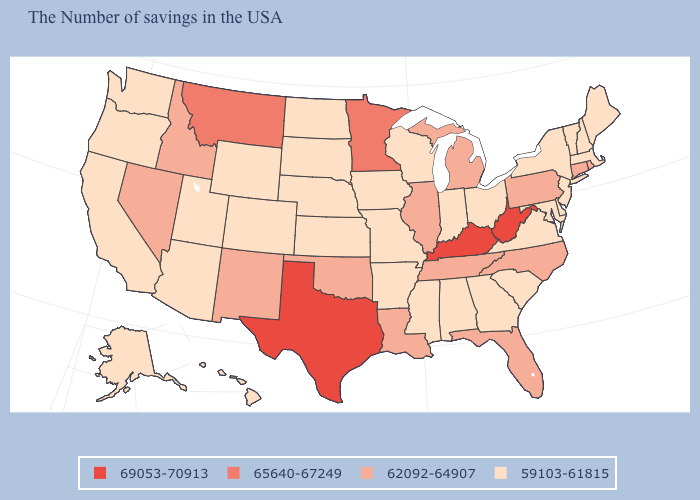What is the lowest value in states that border Tennessee?
Concise answer only. 59103-61815. What is the value of Vermont?
Give a very brief answer. 59103-61815. How many symbols are there in the legend?
Write a very short answer. 4. Name the states that have a value in the range 59103-61815?
Keep it brief. Maine, Massachusetts, New Hampshire, Vermont, New York, New Jersey, Delaware, Maryland, Virginia, South Carolina, Ohio, Georgia, Indiana, Alabama, Wisconsin, Mississippi, Missouri, Arkansas, Iowa, Kansas, Nebraska, South Dakota, North Dakota, Wyoming, Colorado, Utah, Arizona, California, Washington, Oregon, Alaska, Hawaii. What is the value of South Carolina?
Be succinct. 59103-61815. What is the value of Massachusetts?
Quick response, please. 59103-61815. Which states have the highest value in the USA?
Answer briefly. West Virginia, Kentucky, Texas. Does North Carolina have a higher value than Florida?
Write a very short answer. No. Name the states that have a value in the range 62092-64907?
Concise answer only. Rhode Island, Connecticut, Pennsylvania, North Carolina, Florida, Michigan, Tennessee, Illinois, Louisiana, Oklahoma, New Mexico, Idaho, Nevada. Name the states that have a value in the range 65640-67249?
Short answer required. Minnesota, Montana. Name the states that have a value in the range 65640-67249?
Answer briefly. Minnesota, Montana. Name the states that have a value in the range 65640-67249?
Answer briefly. Minnesota, Montana. Which states hav the highest value in the West?
Quick response, please. Montana. Name the states that have a value in the range 69053-70913?
Be succinct. West Virginia, Kentucky, Texas. What is the value of New York?
Short answer required. 59103-61815. 